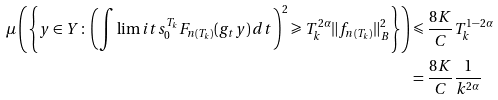Convert formula to latex. <formula><loc_0><loc_0><loc_500><loc_500>\mu \left ( \left \{ y \in Y \colon \left ( \int \lim i t s _ { 0 } ^ { T _ { k } } F _ { n ( T _ { k } ) } ( g _ { t } y ) \, d t \right ) ^ { 2 } \geqslant T _ { k } ^ { 2 \alpha } \| f _ { n ( T _ { k } ) } \| _ { B } ^ { 2 } \right \} \right ) & \leqslant \frac { 8 K } { C } T _ { k } ^ { 1 - 2 \alpha } \\ & = \frac { 8 K } { C } \frac { 1 } { k ^ { 2 \alpha } }</formula> 